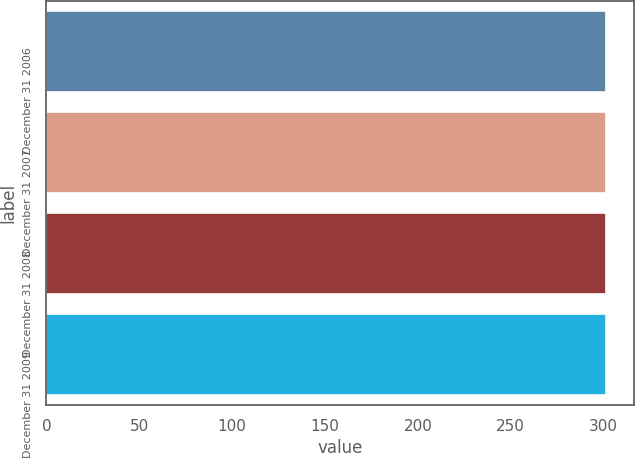<chart> <loc_0><loc_0><loc_500><loc_500><bar_chart><fcel>December 31 2006<fcel>December 31 2007<fcel>December 31 2008<fcel>December 31 2009<nl><fcel>301<fcel>301.1<fcel>301.2<fcel>301.3<nl></chart> 